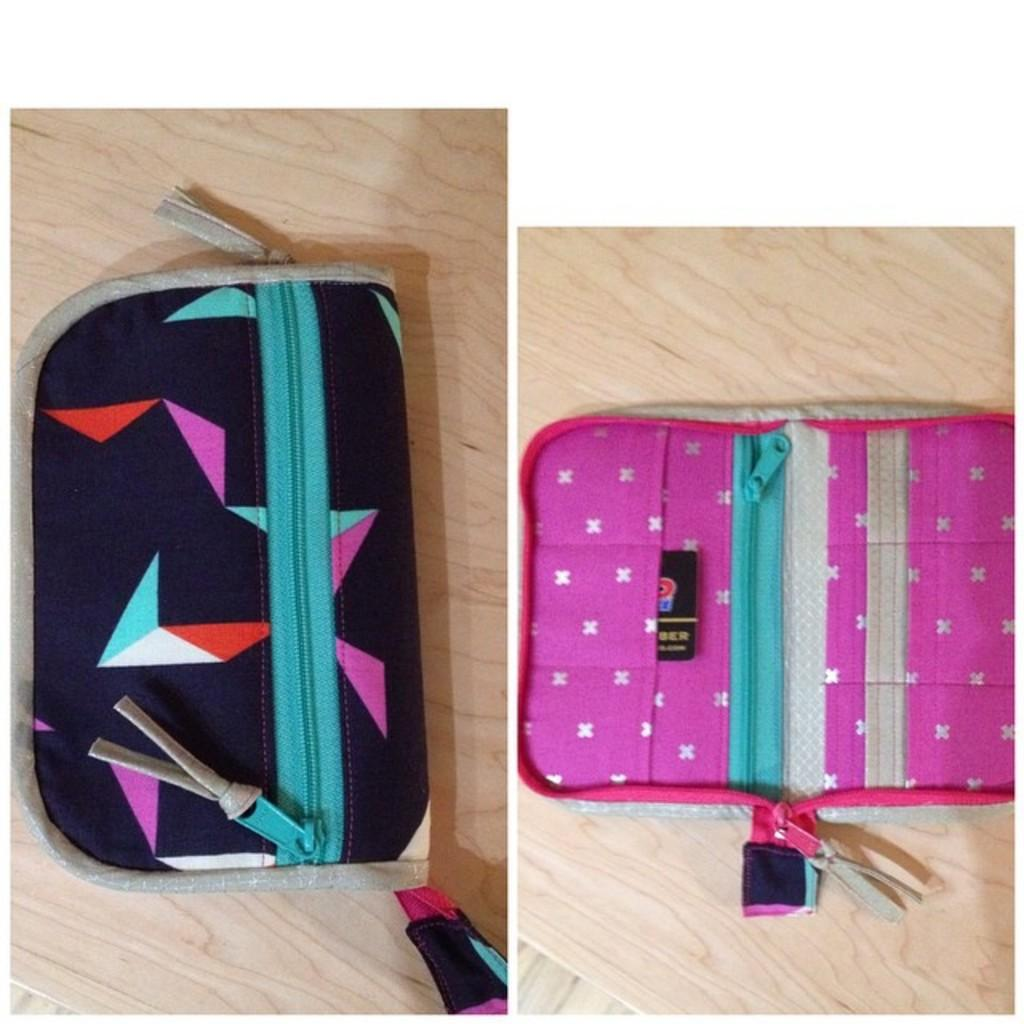What type of objects are featured in the collage photos in the image? The collage photos in the image contain pouches. Can you describe the color of the pouches in the image? The left pouch is of black color, and the right pouch is of pink color. Reasoning: Let' Let's think step by step in order to produce the conversation. We start by identifying the main subject of the image, which is the collage photos of pouches. Then, we describe the colors of the pouches mentioned in the facts. We avoid making any assumptions or asking questions that cannot be answered definitively based on the provided information. Absurd Question/Answer: How many women are visible in the image? There are no women present in the image; it features collage photos of pouches. Is there any snow visible in the image? There is no snow present in the image; it features collage photos of pouches. 